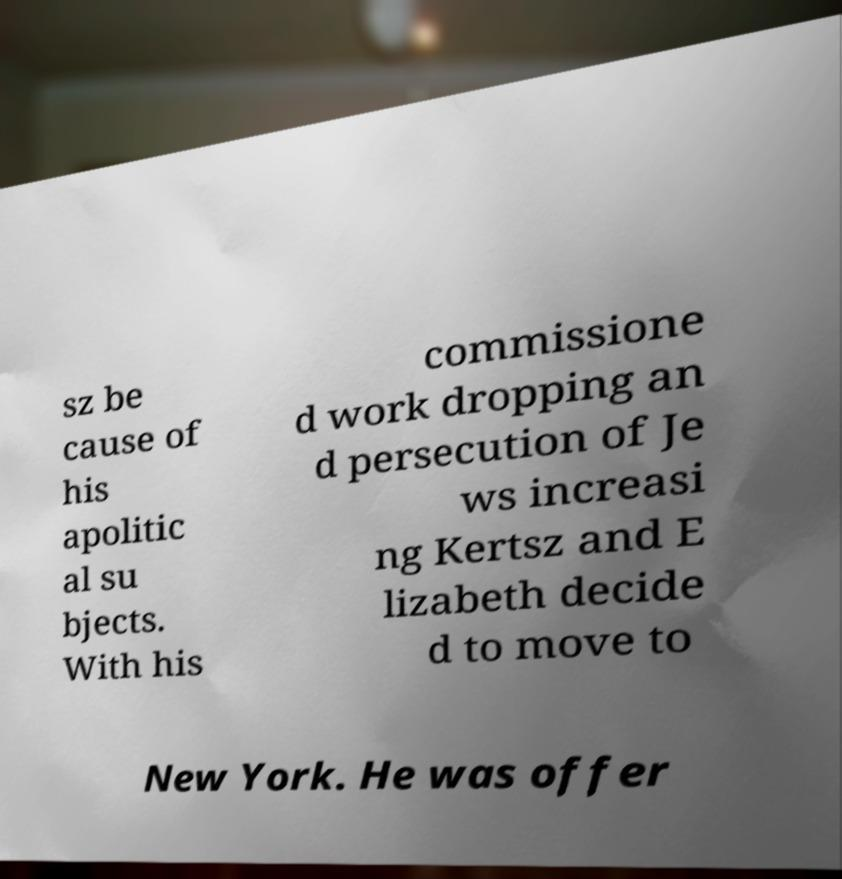Can you accurately transcribe the text from the provided image for me? sz be cause of his apolitic al su bjects. With his commissione d work dropping an d persecution of Je ws increasi ng Kertsz and E lizabeth decide d to move to New York. He was offer 